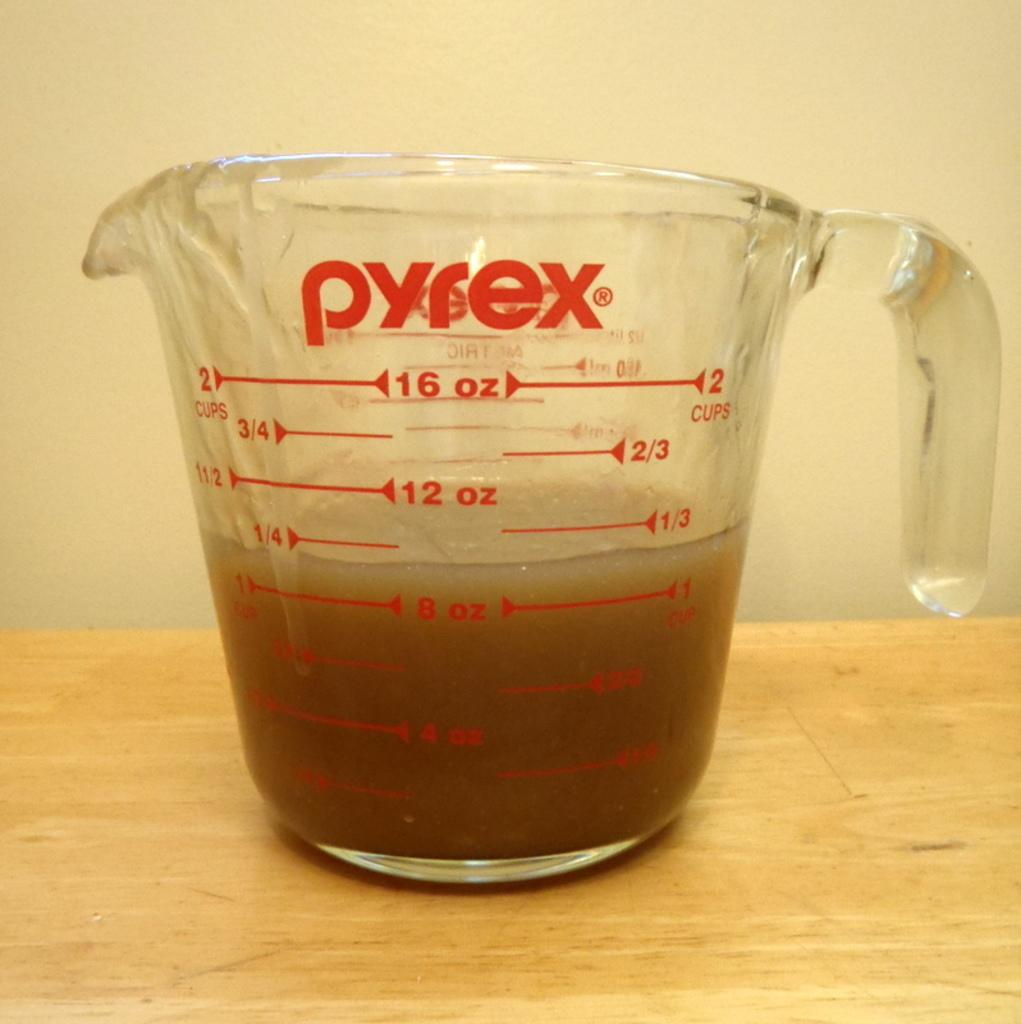<image>
Offer a succinct explanation of the picture presented. A measuring cup by Pyrex is filled to the 8 oz. line. 